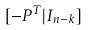<formula> <loc_0><loc_0><loc_500><loc_500>[ - P ^ { T } | I _ { n - k } ]</formula> 